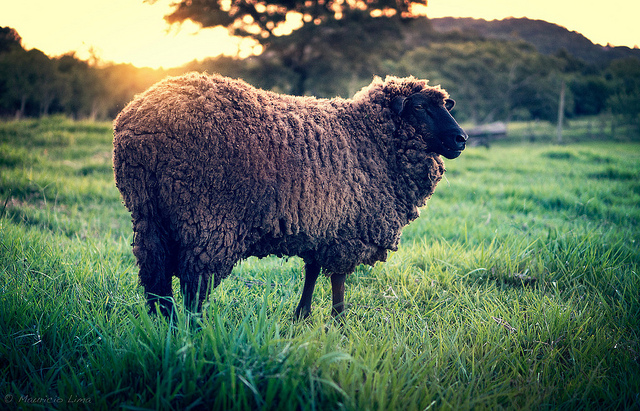If you were to spend a day in this field, what would you want to bring with you? If I were to spend a day in this lovely, serene field, I would bring a picnic blanket, some snacks, a good book, and perhaps a camera to capture the beautiful surroundings. It would be a perfect spot for a peaceful and relaxing day out in nature. 